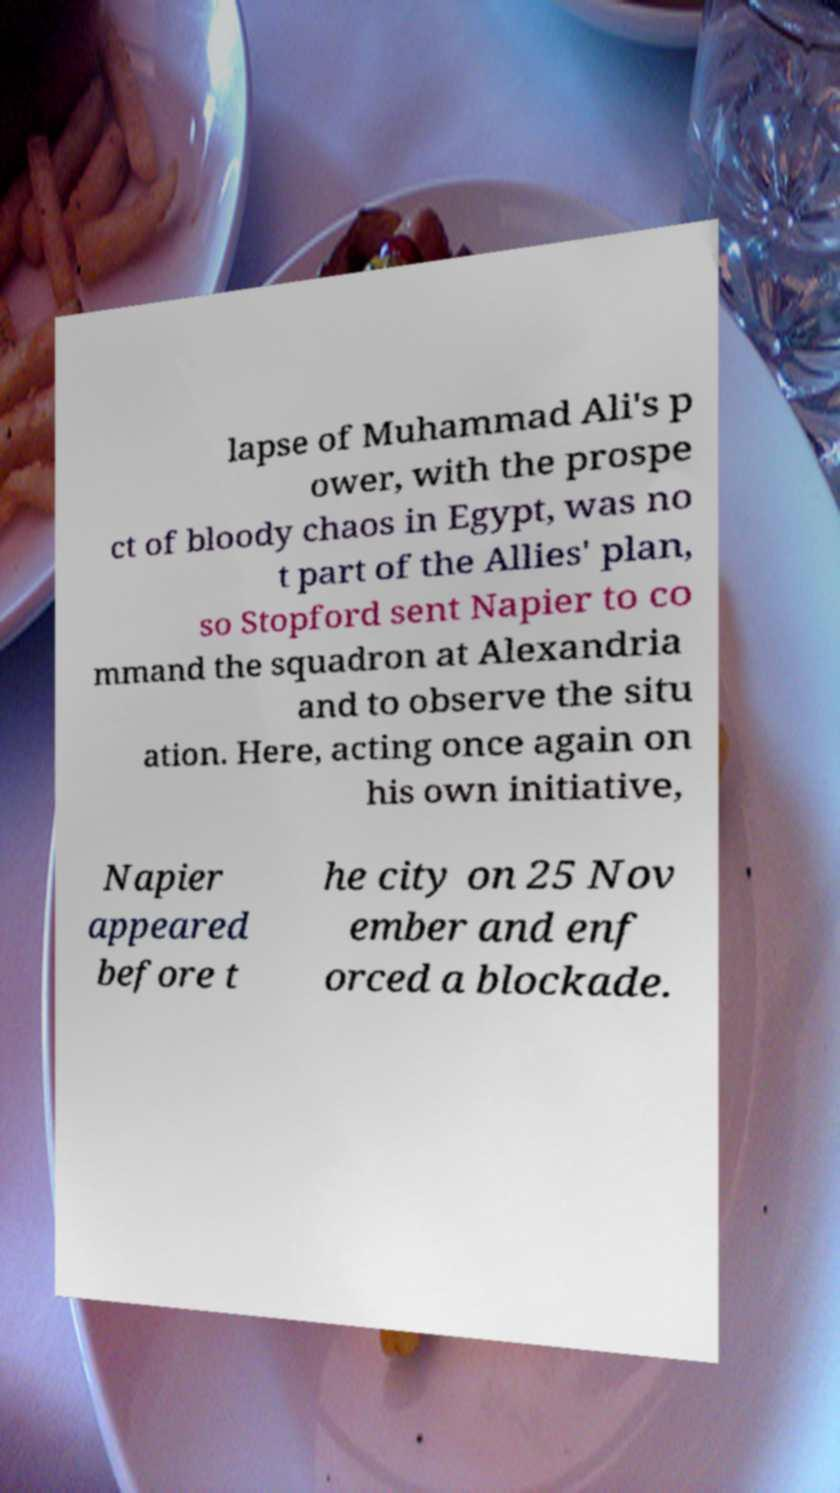What messages or text are displayed in this image? I need them in a readable, typed format. lapse of Muhammad Ali's p ower, with the prospe ct of bloody chaos in Egypt, was no t part of the Allies' plan, so Stopford sent Napier to co mmand the squadron at Alexandria and to observe the situ ation. Here, acting once again on his own initiative, Napier appeared before t he city on 25 Nov ember and enf orced a blockade. 